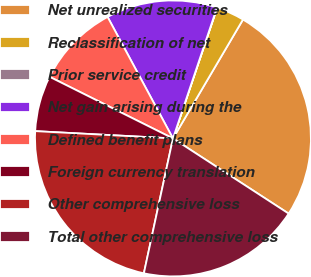Convert chart to OTSL. <chart><loc_0><loc_0><loc_500><loc_500><pie_chart><fcel>Net unrealized securities<fcel>Reclassification of net<fcel>Prior service credit<fcel>Net gain arising during the<fcel>Defined benefit plans<fcel>Foreign currency translation<fcel>Other comprehensive loss<fcel>Total other comprehensive loss<nl><fcel>25.7%<fcel>3.28%<fcel>0.03%<fcel>13.02%<fcel>9.77%<fcel>6.53%<fcel>22.46%<fcel>19.21%<nl></chart> 